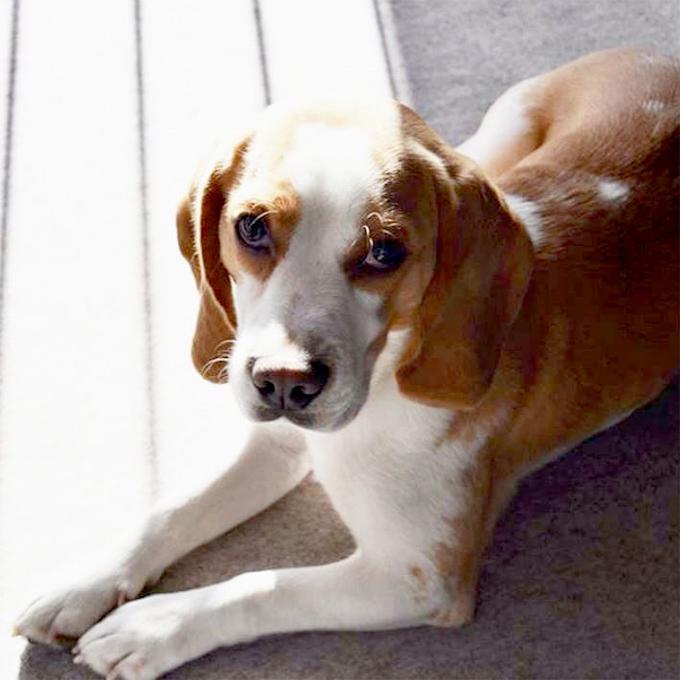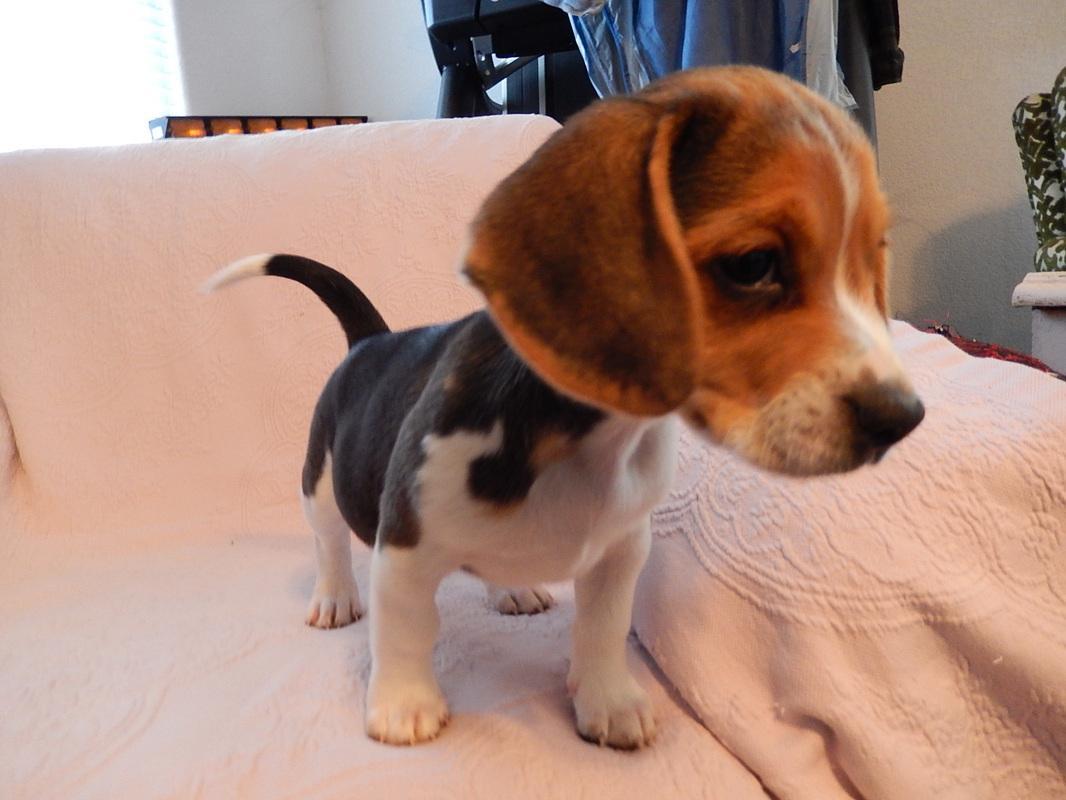The first image is the image on the left, the second image is the image on the right. Given the left and right images, does the statement "At least one of the dogs is inside." hold true? Answer yes or no. Yes. The first image is the image on the left, the second image is the image on the right. Evaluate the accuracy of this statement regarding the images: "At least one dog is one a leash in one of the images.". Is it true? Answer yes or no. No. 